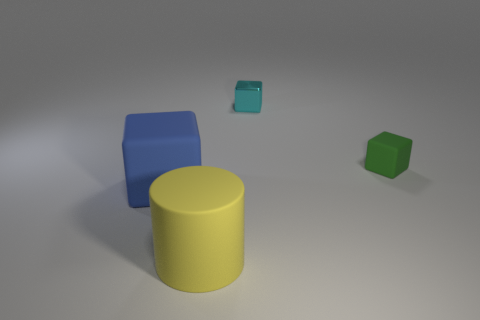Subtract all matte blocks. How many blocks are left? 1 Add 2 big yellow matte cylinders. How many objects exist? 6 Subtract all cyan cubes. How many cubes are left? 2 Subtract all cubes. How many objects are left? 1 Add 4 green rubber objects. How many green rubber objects are left? 5 Add 4 big cyan matte cylinders. How many big cyan matte cylinders exist? 4 Subtract 0 gray cylinders. How many objects are left? 4 Subtract all red cubes. Subtract all red cylinders. How many cubes are left? 3 Subtract all large rubber cubes. Subtract all small blocks. How many objects are left? 1 